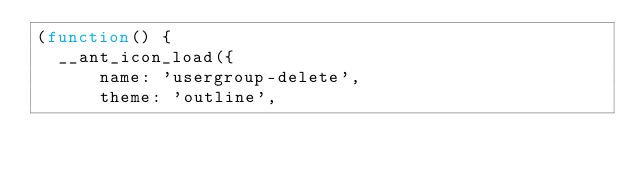<code> <loc_0><loc_0><loc_500><loc_500><_JavaScript_>(function() {
  __ant_icon_load({
      name: 'usergroup-delete',
      theme: 'outline',</code> 